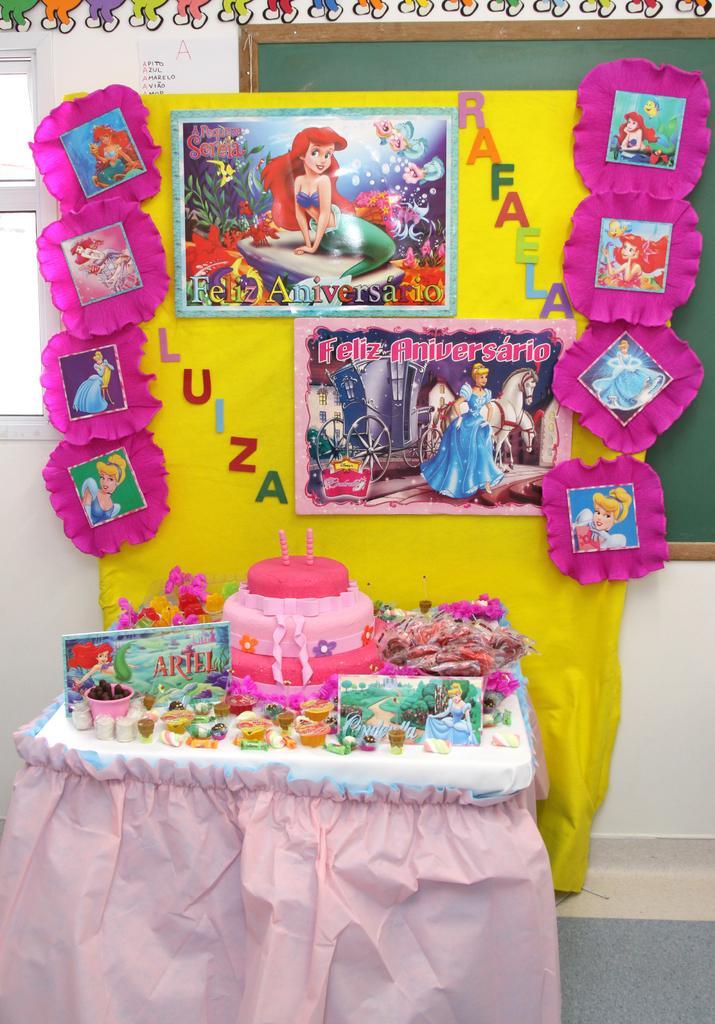Please provide a concise description of this image. In the center of the image there is a table on which there is a cake. In the background of the image there is a wall and posters sticked on it. 